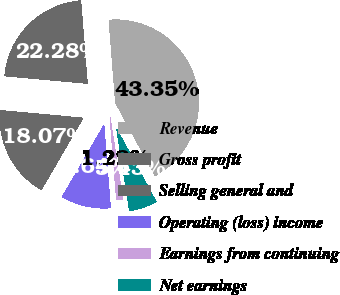Convert chart to OTSL. <chart><loc_0><loc_0><loc_500><loc_500><pie_chart><fcel>Revenue<fcel>Gross profit<fcel>Selling general and<fcel>Operating (loss) income<fcel>Earnings from continuing<fcel>Net earnings<nl><fcel>43.35%<fcel>22.28%<fcel>18.07%<fcel>9.64%<fcel>1.22%<fcel>5.43%<nl></chart> 